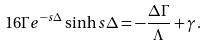Convert formula to latex. <formula><loc_0><loc_0><loc_500><loc_500>1 6 \Gamma e ^ { - s \Delta } \sinh s \Delta = - \frac { \Delta \Gamma } { \Lambda } + \gamma \, .</formula> 